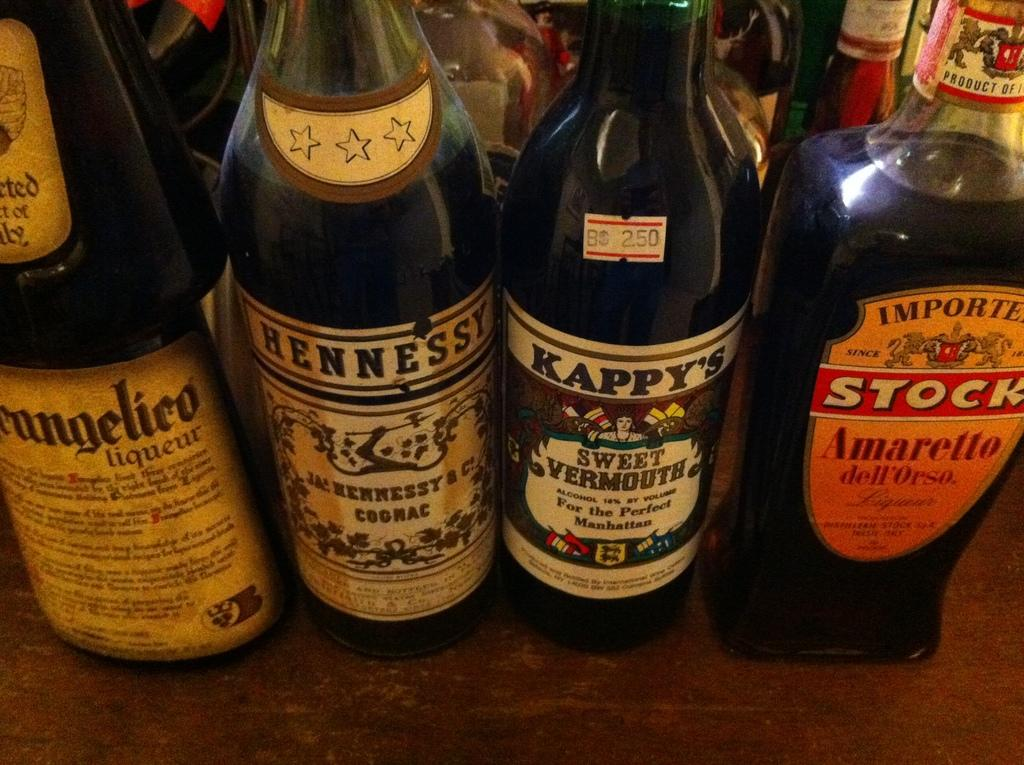What objects are visible in the image? There are bottles in the image. Where are the bottles located? The bottles are on tables. Can you hear the voice of the visitor in the image? There is no reference to a visitor or any voice in the image, so it's not possible to answer that question. 